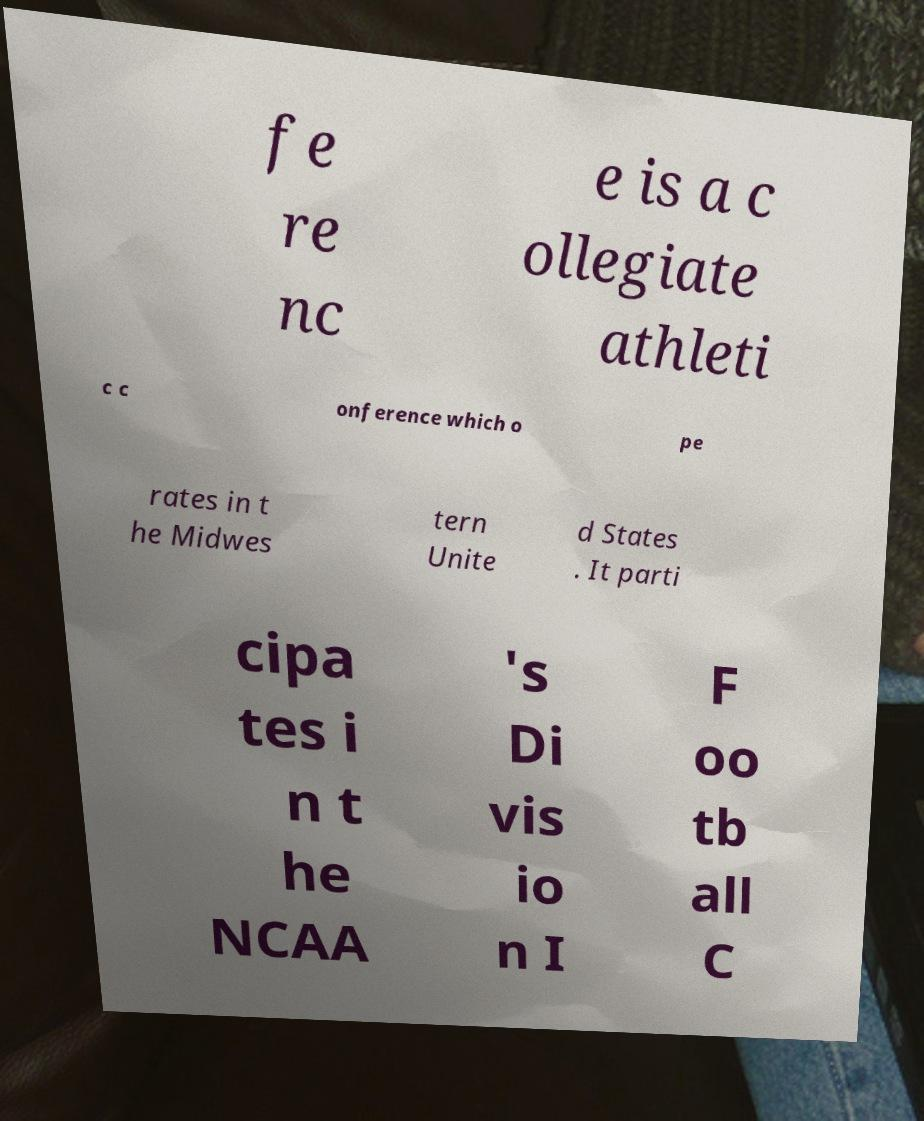Can you read and provide the text displayed in the image?This photo seems to have some interesting text. Can you extract and type it out for me? fe re nc e is a c ollegiate athleti c c onference which o pe rates in t he Midwes tern Unite d States . It parti cipa tes i n t he NCAA 's Di vis io n I F oo tb all C 